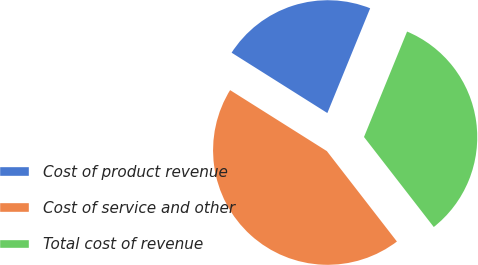Convert chart. <chart><loc_0><loc_0><loc_500><loc_500><pie_chart><fcel>Cost of product revenue<fcel>Cost of service and other<fcel>Total cost of revenue<nl><fcel>22.22%<fcel>44.44%<fcel>33.33%<nl></chart> 